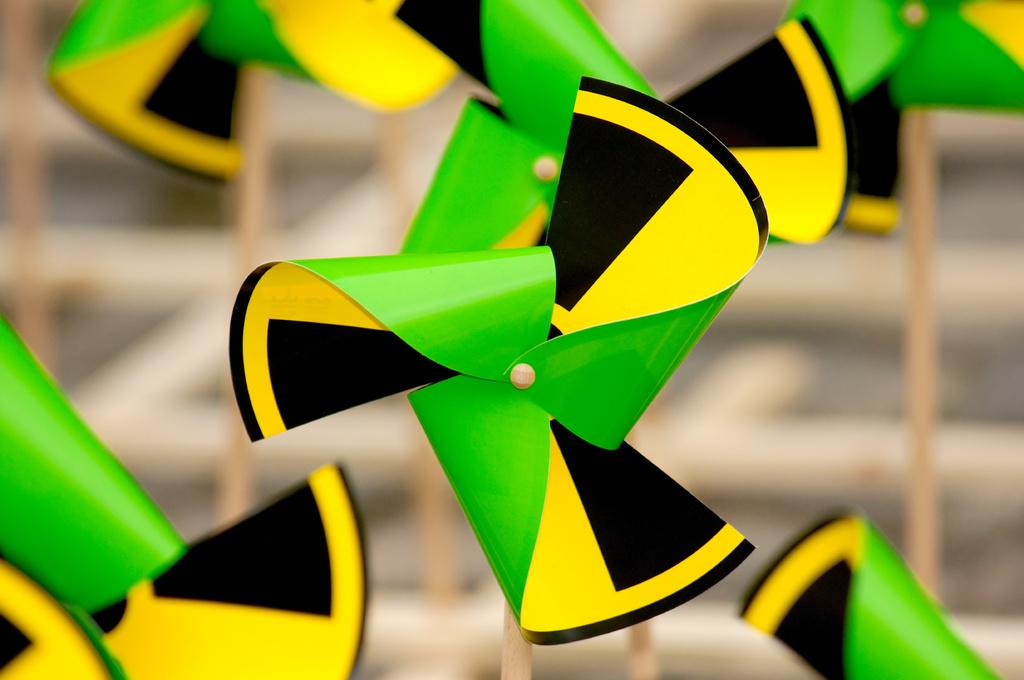What object is the main focus of the image? There is a pinwheel in the image. What colors can be seen on the pinwheel? The pinwheel has yellow, green, and black colors. How would you describe the background of the image? The background of the image is blurred. Are there any other pinwheels visible in the image? Yes, there are more pinwheels visible in the background. What type of governor is featured in the image? There is no governor present in the image; it features a pinwheel. What kind of apparatus is used to spin the pinwheel in the image? The image does not show the pinwheel being spun, so it is not possible to determine what kind of apparatus might be used. 